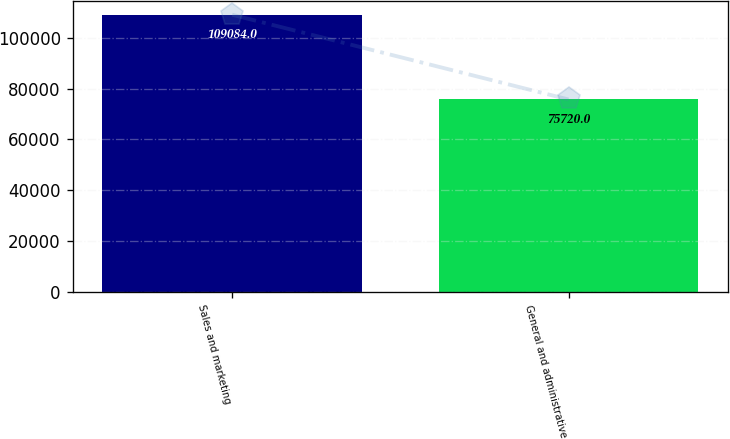Convert chart to OTSL. <chart><loc_0><loc_0><loc_500><loc_500><bar_chart><fcel>Sales and marketing<fcel>General and administrative<nl><fcel>109084<fcel>75720<nl></chart> 